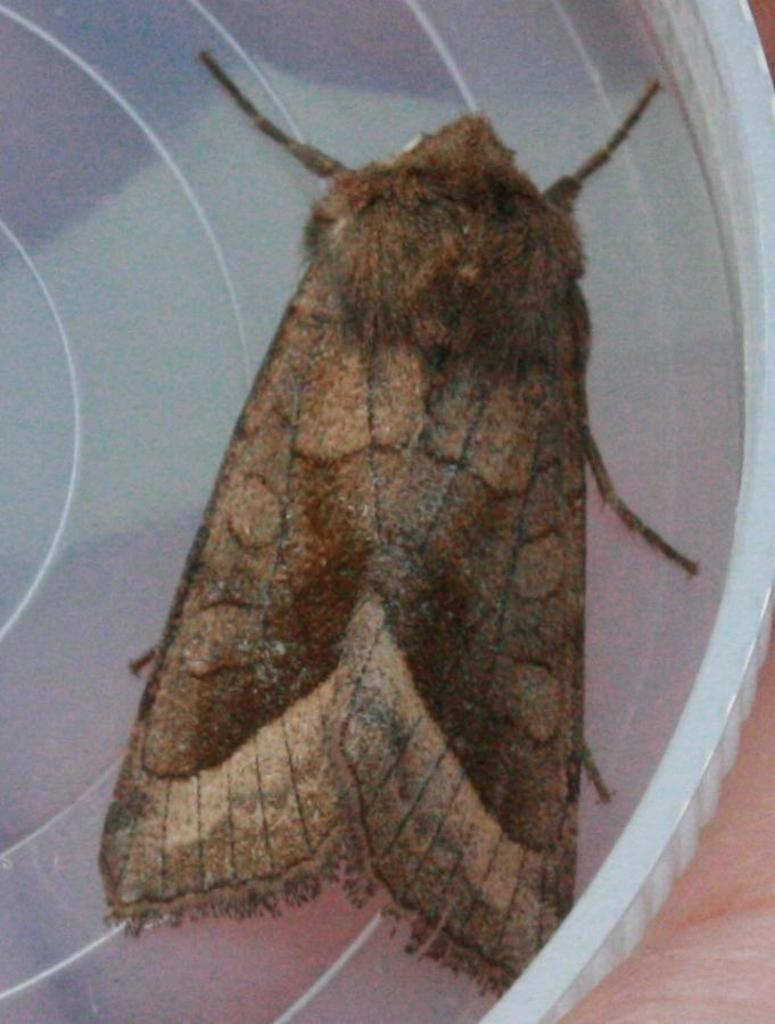What type of creature is in the image? There is an insect in the image. Where is the insect located? The insect is in a plastic tray. What is the plastic tray placed on? The plastic tray is on a table. What year is the insect performing on stage in the image? There is no stage or performance in the image, and no year is mentioned or implied. 